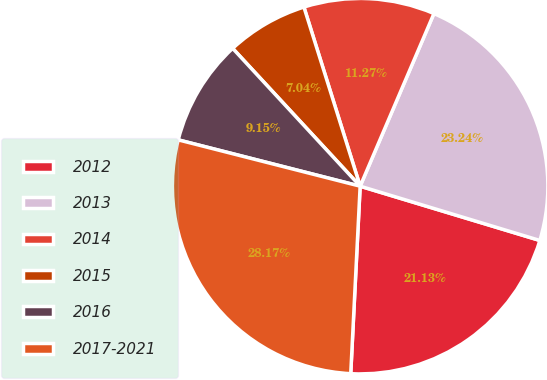<chart> <loc_0><loc_0><loc_500><loc_500><pie_chart><fcel>2012<fcel>2013<fcel>2014<fcel>2015<fcel>2016<fcel>2017-2021<nl><fcel>21.13%<fcel>23.24%<fcel>11.27%<fcel>7.04%<fcel>9.15%<fcel>28.17%<nl></chart> 